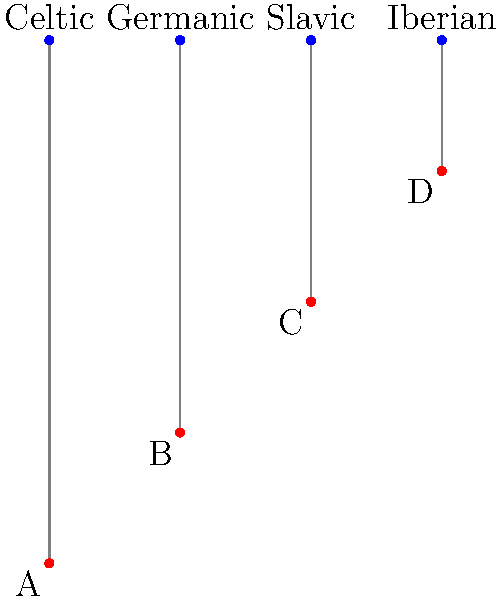Match the ancient European tribal artifacts (A, B, C, D) to their corresponding tribes based on the connections shown in the network diagram. Which artifact belongs to the Germanic tribe? To determine which artifact belongs to the Germanic tribe, we need to follow these steps:

1. Identify the position of the Germanic tribe in the network:
   The Germanic tribe is the second from the left among the tribe names at the top.

2. Trace the connection from the Germanic tribe:
   There is a gray line connecting the Germanic tribe to one of the artifacts below.

3. Identify the artifact connected to the Germanic tribe:
   The line from the Germanic tribe leads to the artifact labeled "B".

4. Verify the connection:
   Double-check that there are no other connections to the Germanic tribe and that "B" is not connected to any other tribe.

5. Conclude:
   Based on the network diagram, artifact B is connected to the Germanic tribe.
Answer: B 